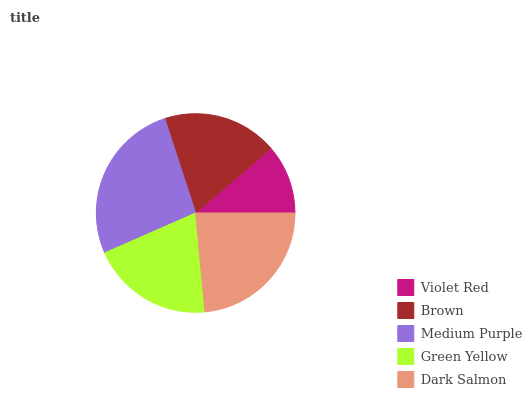Is Violet Red the minimum?
Answer yes or no. Yes. Is Medium Purple the maximum?
Answer yes or no. Yes. Is Brown the minimum?
Answer yes or no. No. Is Brown the maximum?
Answer yes or no. No. Is Brown greater than Violet Red?
Answer yes or no. Yes. Is Violet Red less than Brown?
Answer yes or no. Yes. Is Violet Red greater than Brown?
Answer yes or no. No. Is Brown less than Violet Red?
Answer yes or no. No. Is Green Yellow the high median?
Answer yes or no. Yes. Is Green Yellow the low median?
Answer yes or no. Yes. Is Medium Purple the high median?
Answer yes or no. No. Is Violet Red the low median?
Answer yes or no. No. 